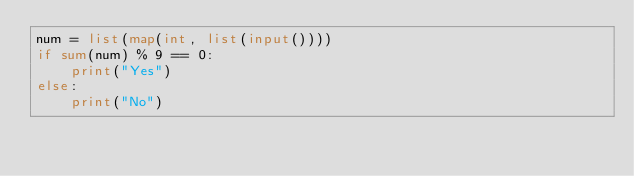Convert code to text. <code><loc_0><loc_0><loc_500><loc_500><_Python_>num = list(map(int, list(input())))
if sum(num) % 9 == 0:
    print("Yes")
else:
    print("No")

</code> 